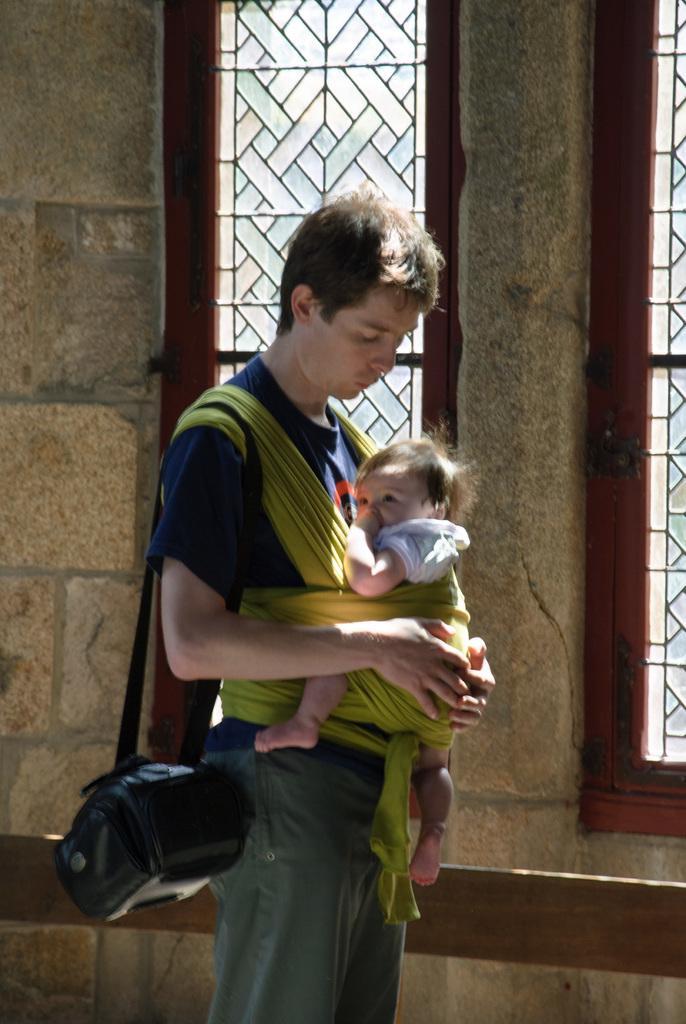Please provide a concise description of this image. In this picture we can see a person and a baby and in the background we can see a wall, windows. 